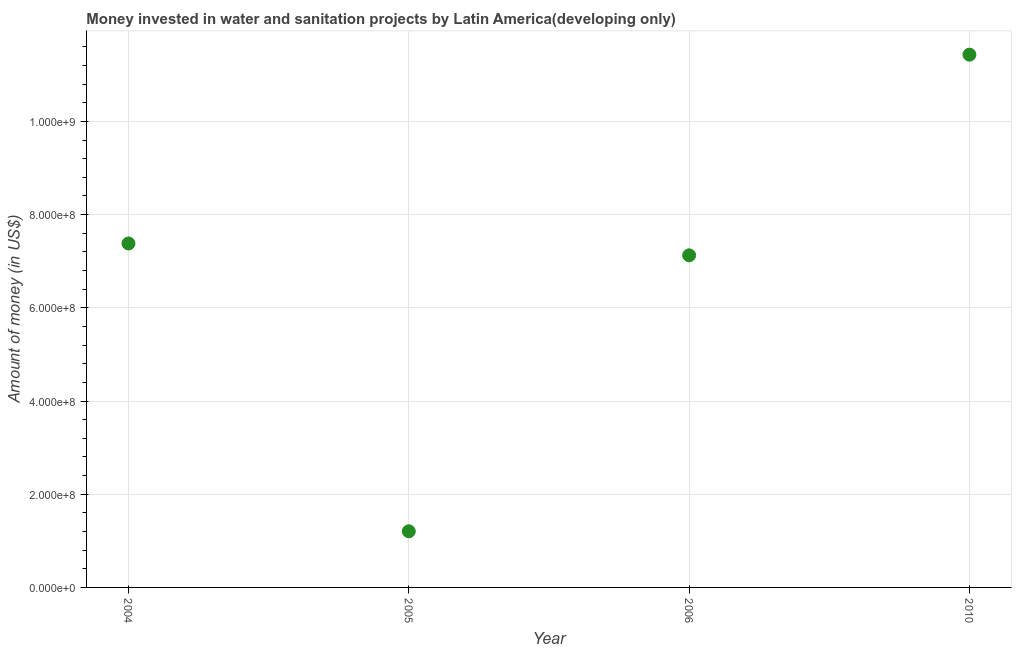What is the investment in 2006?
Give a very brief answer. 7.13e+08. Across all years, what is the maximum investment?
Keep it short and to the point. 1.14e+09. Across all years, what is the minimum investment?
Offer a very short reply. 1.20e+08. In which year was the investment maximum?
Your answer should be very brief. 2010. In which year was the investment minimum?
Give a very brief answer. 2005. What is the sum of the investment?
Your answer should be compact. 2.71e+09. What is the difference between the investment in 2005 and 2006?
Give a very brief answer. -5.92e+08. What is the average investment per year?
Your answer should be compact. 6.79e+08. What is the median investment?
Provide a short and direct response. 7.25e+08. What is the ratio of the investment in 2004 to that in 2006?
Keep it short and to the point. 1.04. Is the investment in 2004 less than that in 2010?
Make the answer very short. Yes. Is the difference between the investment in 2006 and 2010 greater than the difference between any two years?
Offer a terse response. No. What is the difference between the highest and the second highest investment?
Make the answer very short. 4.05e+08. Is the sum of the investment in 2004 and 2005 greater than the maximum investment across all years?
Your answer should be very brief. No. What is the difference between the highest and the lowest investment?
Ensure brevity in your answer.  1.02e+09. Does the investment monotonically increase over the years?
Your answer should be compact. No. How many dotlines are there?
Offer a very short reply. 1. How many years are there in the graph?
Your answer should be very brief. 4. Does the graph contain any zero values?
Make the answer very short. No. Does the graph contain grids?
Your answer should be very brief. Yes. What is the title of the graph?
Provide a succinct answer. Money invested in water and sanitation projects by Latin America(developing only). What is the label or title of the X-axis?
Offer a terse response. Year. What is the label or title of the Y-axis?
Keep it short and to the point. Amount of money (in US$). What is the Amount of money (in US$) in 2004?
Your answer should be very brief. 7.38e+08. What is the Amount of money (in US$) in 2005?
Provide a succinct answer. 1.20e+08. What is the Amount of money (in US$) in 2006?
Your response must be concise. 7.13e+08. What is the Amount of money (in US$) in 2010?
Give a very brief answer. 1.14e+09. What is the difference between the Amount of money (in US$) in 2004 and 2005?
Offer a terse response. 6.18e+08. What is the difference between the Amount of money (in US$) in 2004 and 2006?
Your answer should be compact. 2.54e+07. What is the difference between the Amount of money (in US$) in 2004 and 2010?
Provide a short and direct response. -4.05e+08. What is the difference between the Amount of money (in US$) in 2005 and 2006?
Provide a short and direct response. -5.92e+08. What is the difference between the Amount of money (in US$) in 2005 and 2010?
Your answer should be compact. -1.02e+09. What is the difference between the Amount of money (in US$) in 2006 and 2010?
Your response must be concise. -4.31e+08. What is the ratio of the Amount of money (in US$) in 2004 to that in 2005?
Make the answer very short. 6.13. What is the ratio of the Amount of money (in US$) in 2004 to that in 2006?
Provide a succinct answer. 1.04. What is the ratio of the Amount of money (in US$) in 2004 to that in 2010?
Offer a terse response. 0.65. What is the ratio of the Amount of money (in US$) in 2005 to that in 2006?
Provide a succinct answer. 0.17. What is the ratio of the Amount of money (in US$) in 2005 to that in 2010?
Your answer should be compact. 0.1. What is the ratio of the Amount of money (in US$) in 2006 to that in 2010?
Offer a very short reply. 0.62. 